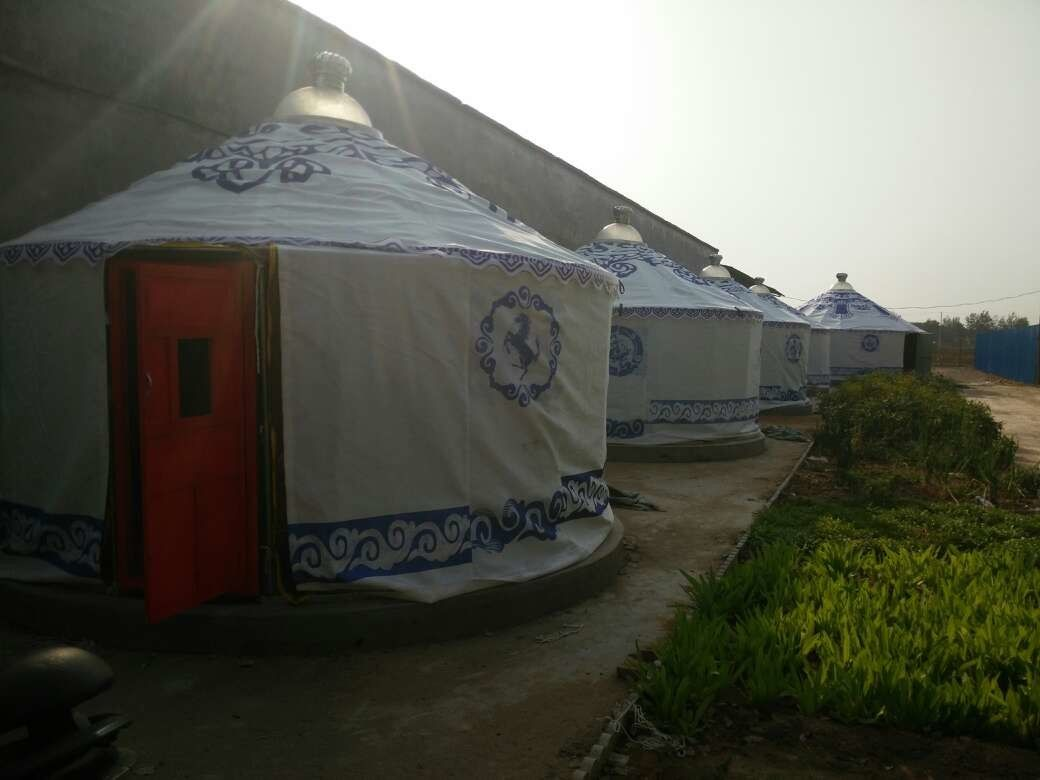Imagine if these yurts could talk. What stories might they tell about the people who have lived in them? If these yurts could talk, they would share tales of nomadic journeys across vast steppes and deserts. They would recount the laughter and songs heard during lively family gatherings and cultural ceremonies, the smell of traditional meals cooked over open fires, and the warmth shared during cold nights. They would speak of the resilience of the people who lived in them, adapting to the challenges of their environment and celebrating their heritage through the generations. These yurts would also tell of travelers and guests who found temporary refuge within their walls, exchanging stories and forging connections with the local community. Each yurt would be a repository of rich, layered histories, filled with moments of joy, hardship, and camaraderie. What impact might this kind of cultural event have on the local community and visitors? Cultural events like this can significantly benefit both the local community and visitors. For the local community, such events can foster a sense of pride and continuity in their cultural heritage. It provides an opportunity to showcase their traditions, crafts, music, and cuisine to a broader audience, which can lead to increased community cohesion and identity. Economically, these events can boost local businesses and create temporary job opportunities, contributing to the local economy. For visitors, these events offer an immersive educational experience, fostering greater understanding and appreciation of different cultures. Participating in such events can also break down cultural barriers, promote diversity, and strengthen social bonds. Overall, the impact is one of mutual enrichment, cultural exchange, and community development. 